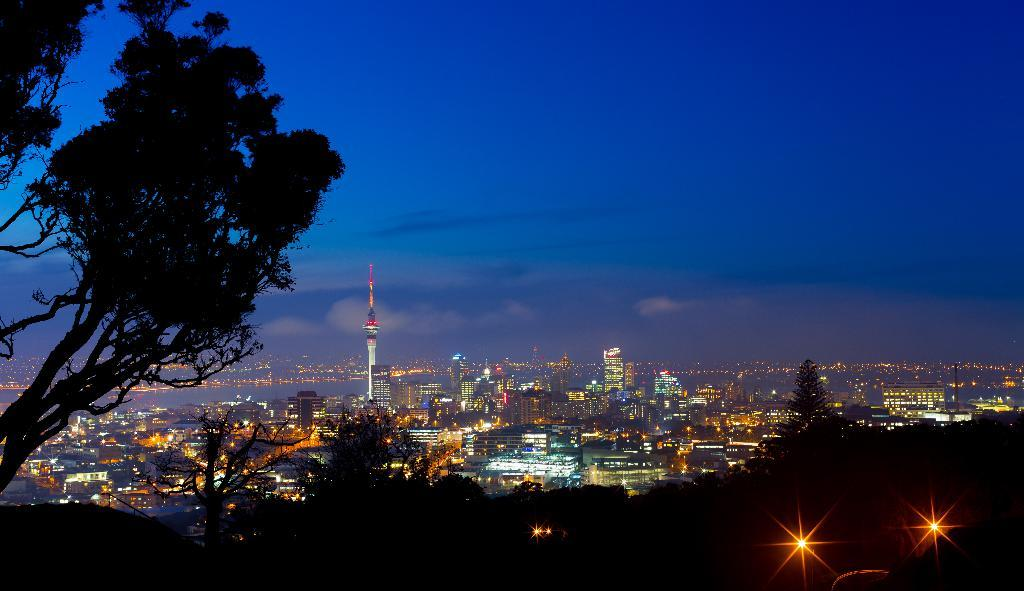What type of natural elements can be seen in the image? There are trees in the image. What type of man-made structures are present in the image? There are buildings in the image. What body of water is visible in the image? There is a river in the image. What type of coat is hanging on the tree in the image? There is no coat present in the image; it only features trees, buildings, and a river. 